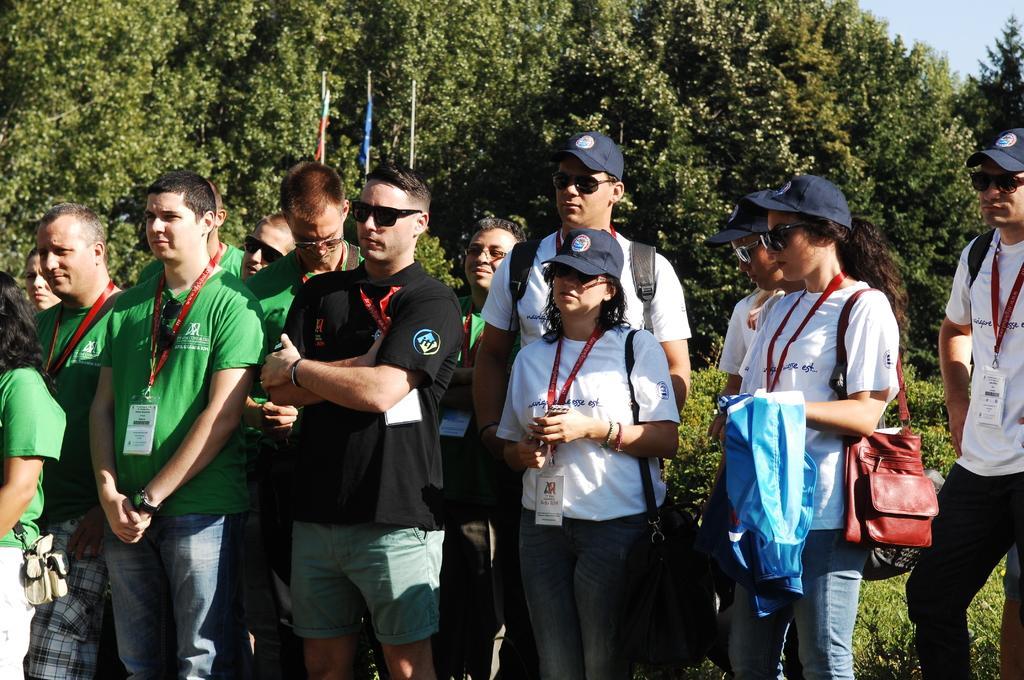Please provide a concise description of this image. In this picture there are group of people those who are standing in the center of the image and there are trees in the background area of the image. 